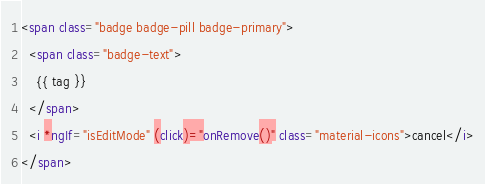Convert code to text. <code><loc_0><loc_0><loc_500><loc_500><_HTML_><span class="badge badge-pill badge-primary">
  <span class="badge-text">
    {{ tag }}
  </span>
  <i *ngIf="isEditMode" (click)="onRemove()" class="material-icons">cancel</i>
</span></code> 